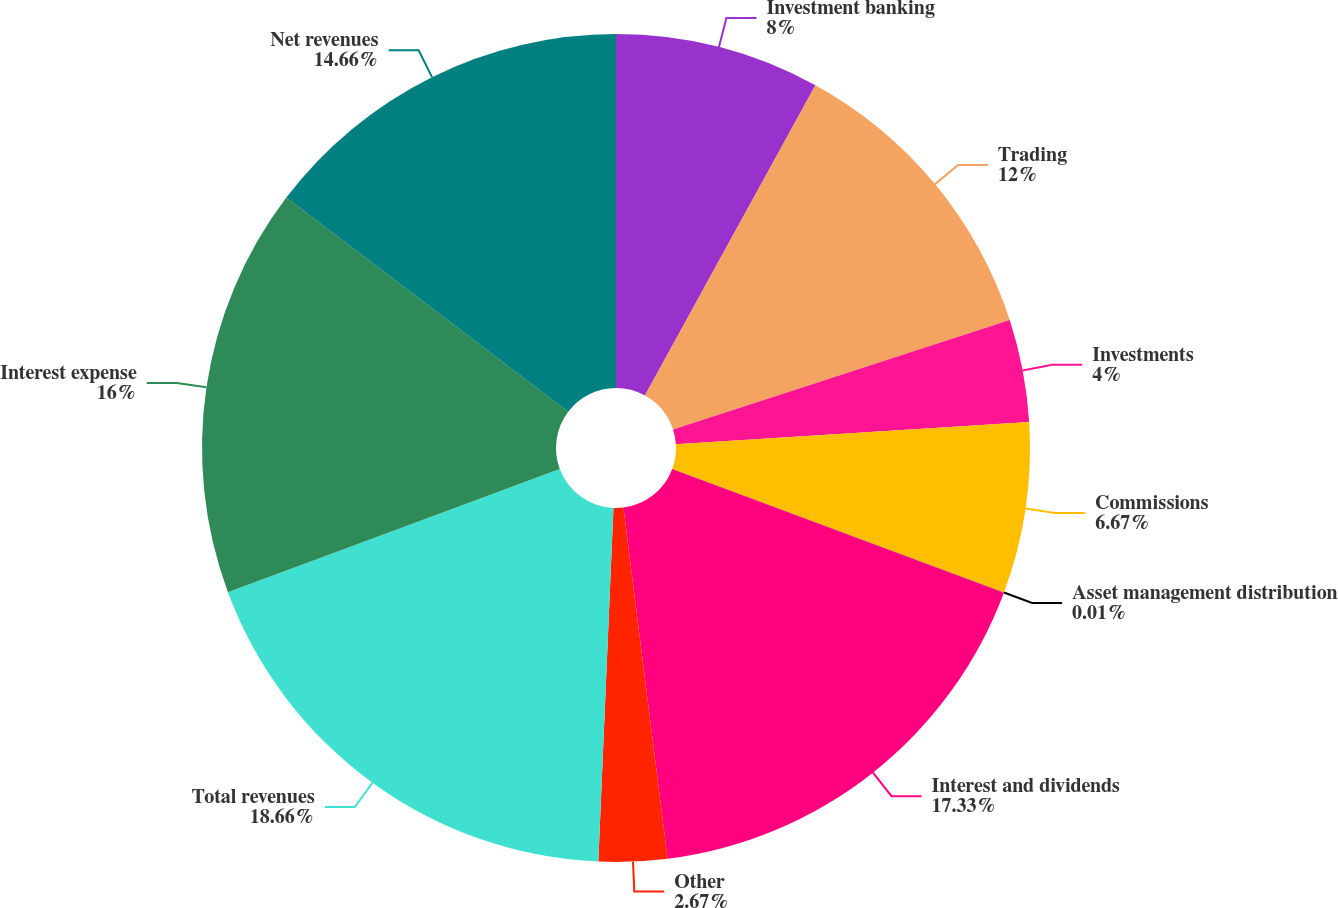Convert chart to OTSL. <chart><loc_0><loc_0><loc_500><loc_500><pie_chart><fcel>Investment banking<fcel>Trading<fcel>Investments<fcel>Commissions<fcel>Asset management distribution<fcel>Interest and dividends<fcel>Other<fcel>Total revenues<fcel>Interest expense<fcel>Net revenues<nl><fcel>8.0%<fcel>12.0%<fcel>4.0%<fcel>6.67%<fcel>0.01%<fcel>17.33%<fcel>2.67%<fcel>18.66%<fcel>16.0%<fcel>14.66%<nl></chart> 